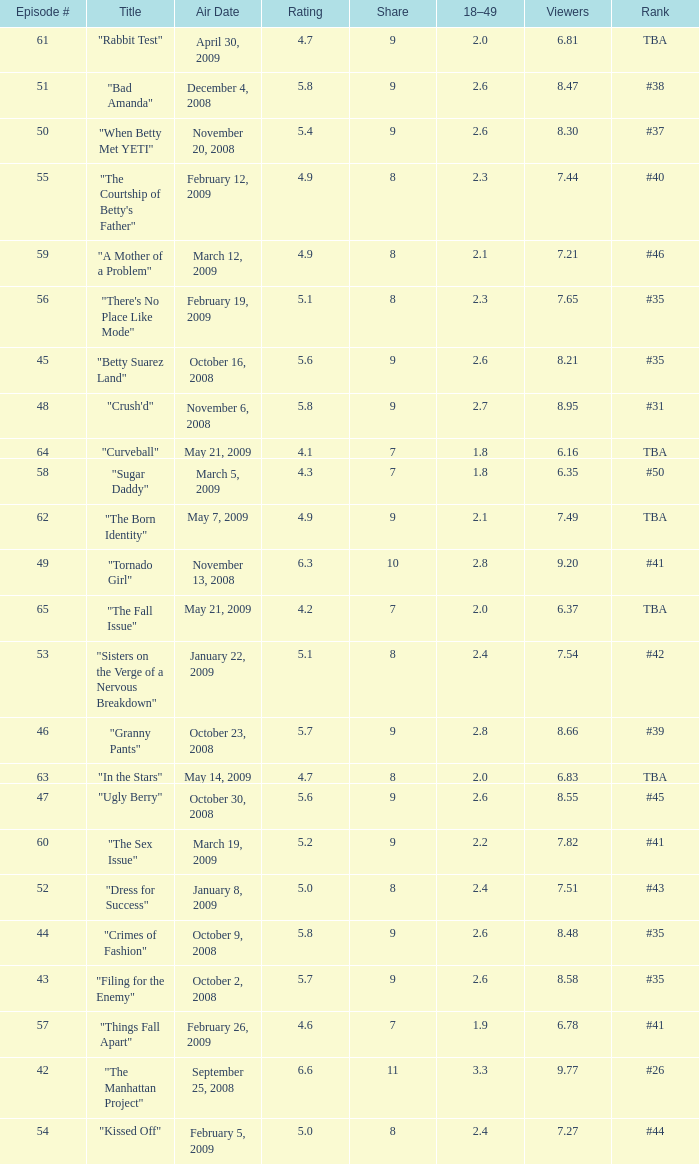What is the average Episode # with a 7 share and 18–49 is less than 2 and the Air Date of may 21, 2009? 64.0. 